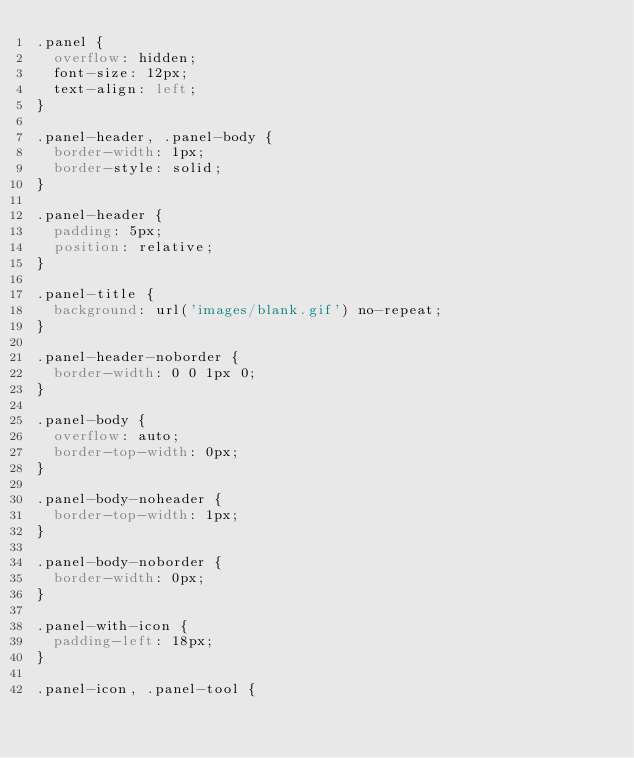<code> <loc_0><loc_0><loc_500><loc_500><_CSS_>.panel {
	overflow: hidden;
	font-size: 12px;
	text-align: left;
}

.panel-header, .panel-body {
	border-width: 1px;
	border-style: solid;
}

.panel-header {
	padding: 5px;
	position: relative;
}

.panel-title {
	background: url('images/blank.gif') no-repeat;
}

.panel-header-noborder {
	border-width: 0 0 1px 0;
}

.panel-body {
	overflow: auto;
	border-top-width: 0px;
}

.panel-body-noheader {
	border-top-width: 1px;
}

.panel-body-noborder {
	border-width: 0px;
}

.panel-with-icon {
	padding-left: 18px;
}

.panel-icon, .panel-tool {</code> 